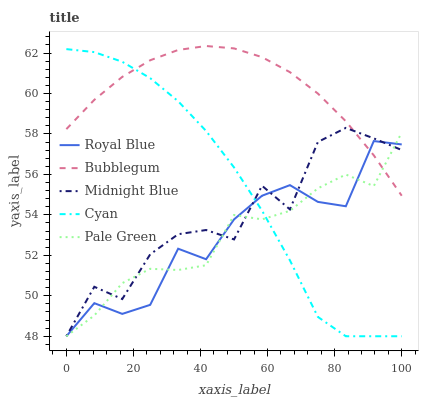Does Midnight Blue have the minimum area under the curve?
Answer yes or no. No. Does Midnight Blue have the maximum area under the curve?
Answer yes or no. No. Is Pale Green the smoothest?
Answer yes or no. No. Is Pale Green the roughest?
Answer yes or no. No. Does Bubblegum have the lowest value?
Answer yes or no. No. Does Pale Green have the highest value?
Answer yes or no. No. 